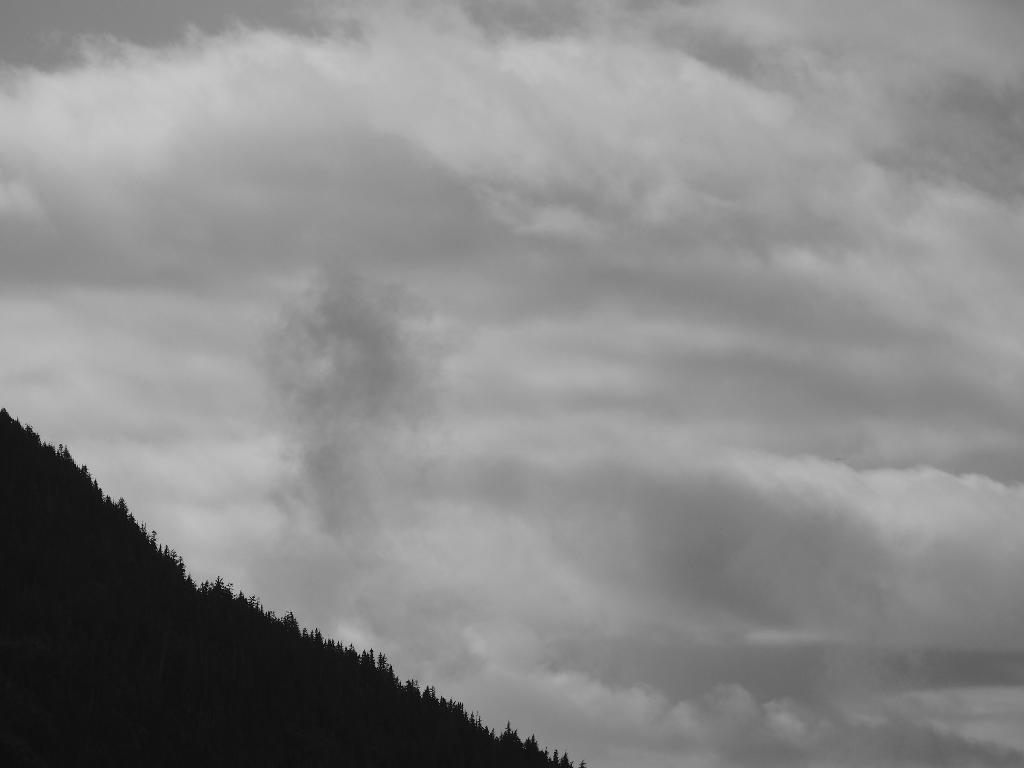What type of vegetation can be seen in the image? There are trees in the image. What part of the natural environment is visible in the image? The sky is visible in the background of the image. What type of game is being played by the trees in the image? There is no game being played by the trees in the image, as trees are inanimate objects and cannot play games. 